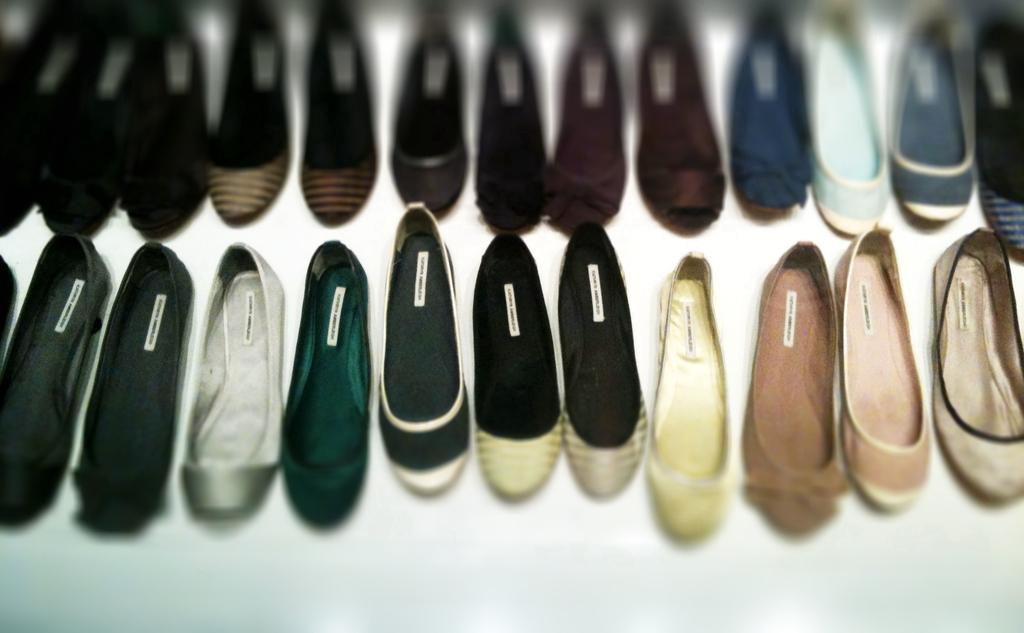What type of objects are present in the image? There are shoes in the image. How do the shoes differ from one another? The shoes come in different types and colors. What is located at the bottom of the image? There is a table visible at the bottom of the image. How many chickens are sitting on the shoes in the image? There are no chickens present in the image; it only features shoes and a table. What type of stitch is used to create the shoes in the image? The image does not provide information about the stitching used to create the shoes. 